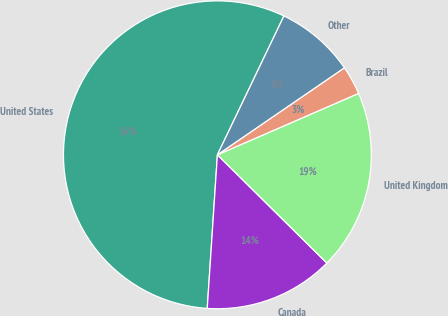Convert chart to OTSL. <chart><loc_0><loc_0><loc_500><loc_500><pie_chart><fcel>United States<fcel>Canada<fcel>United Kingdom<fcel>Brazil<fcel>Other<nl><fcel>56.06%<fcel>13.64%<fcel>18.94%<fcel>3.03%<fcel>8.33%<nl></chart> 